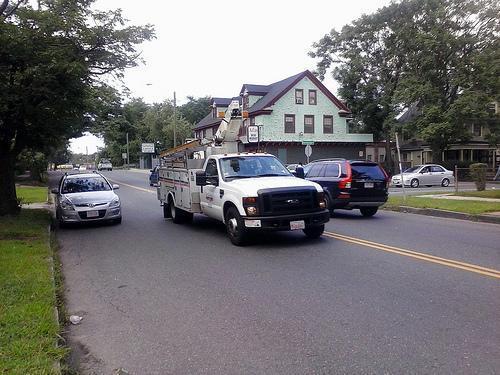How many headlights are on the front of the white truck?
Give a very brief answer. 2. 